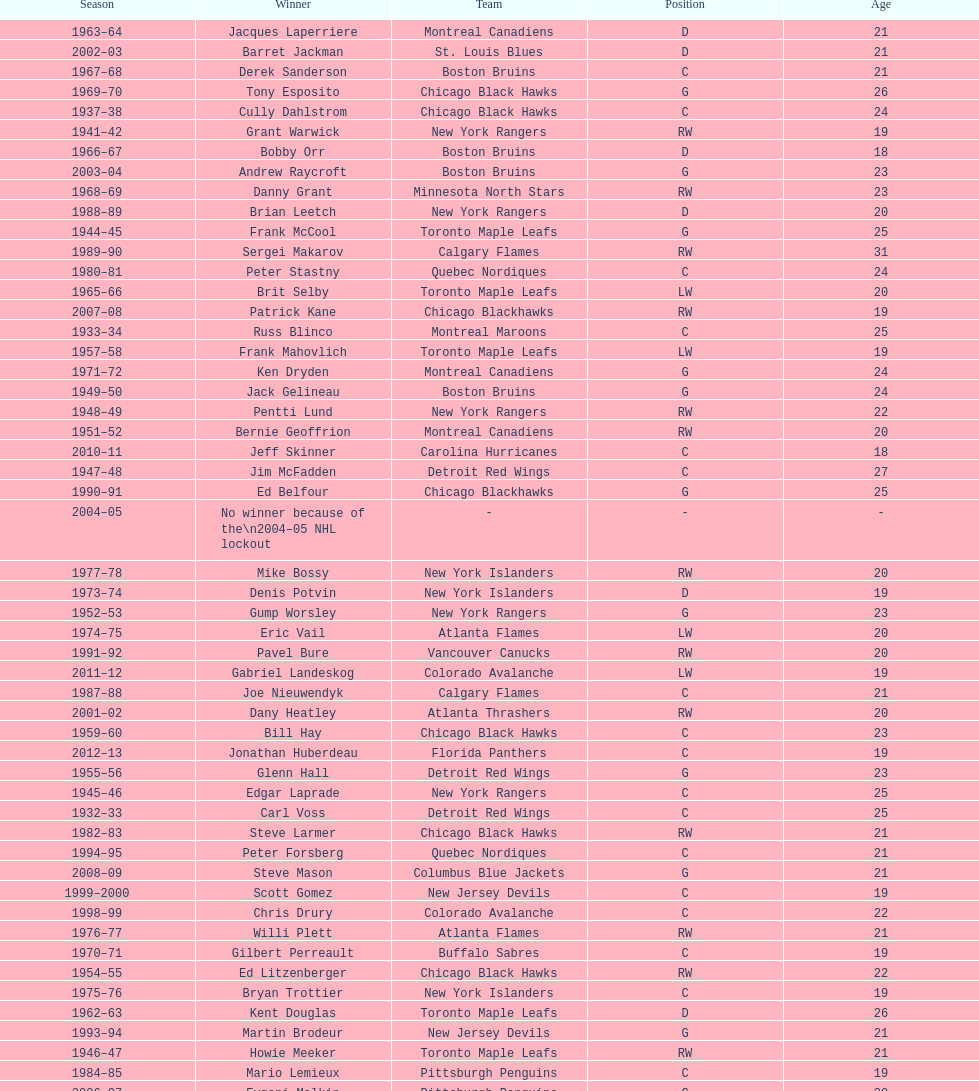Which team has the highest number of consecutive calder memorial trophy winners? Toronto Maple Leafs. 